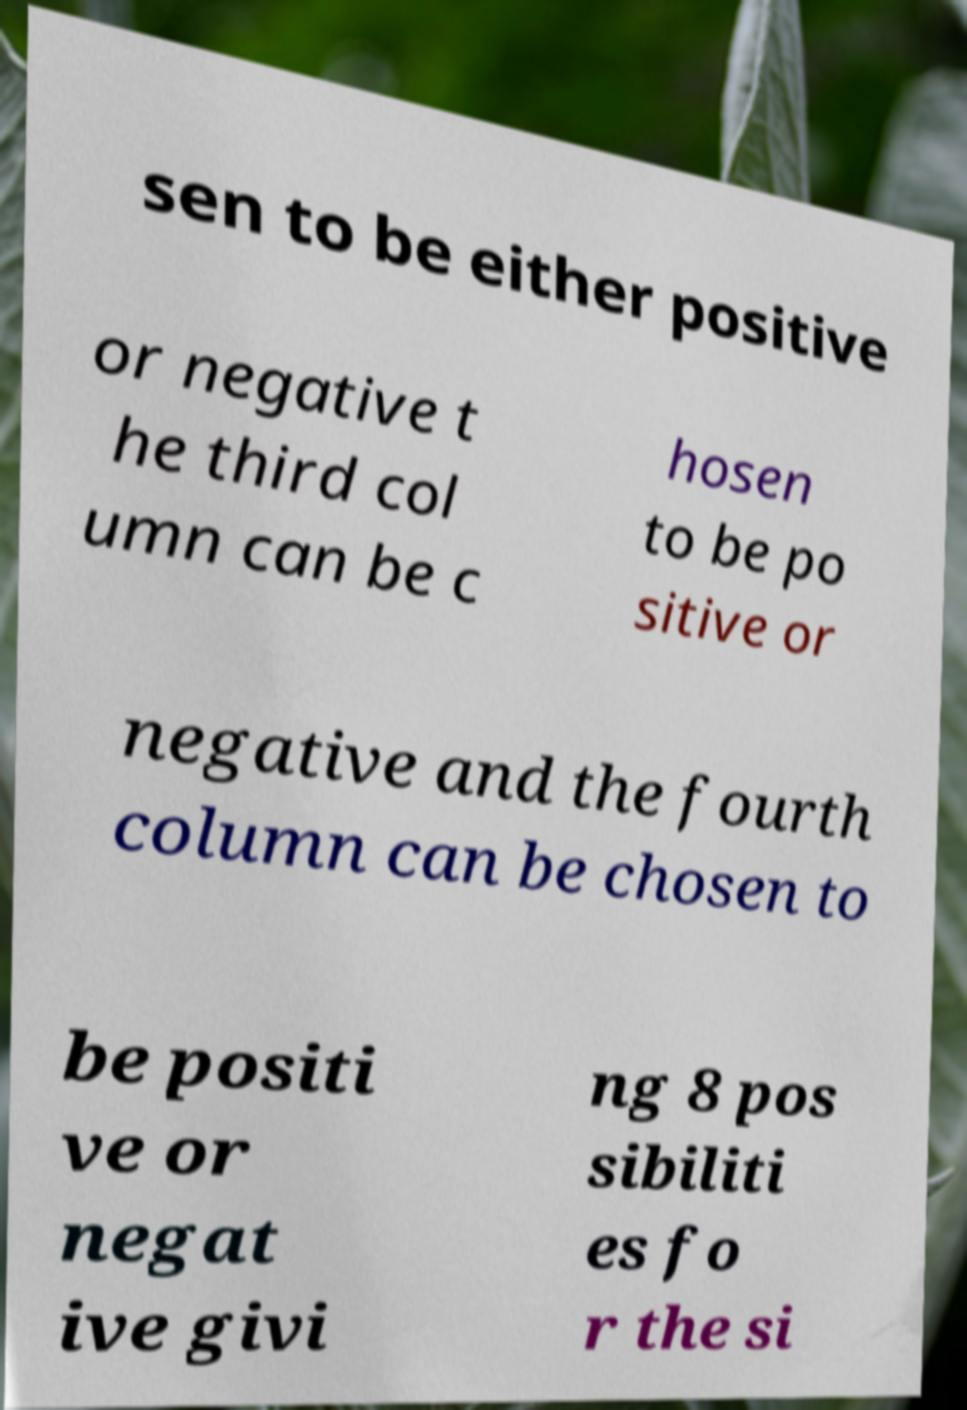Please read and relay the text visible in this image. What does it say? sen to be either positive or negative t he third col umn can be c hosen to be po sitive or negative and the fourth column can be chosen to be positi ve or negat ive givi ng 8 pos sibiliti es fo r the si 